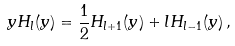<formula> <loc_0><loc_0><loc_500><loc_500>y H _ { l } ( y ) = \frac { 1 } { 2 } H _ { l + 1 } ( y ) + l H _ { l - 1 } ( y ) \, ,</formula> 